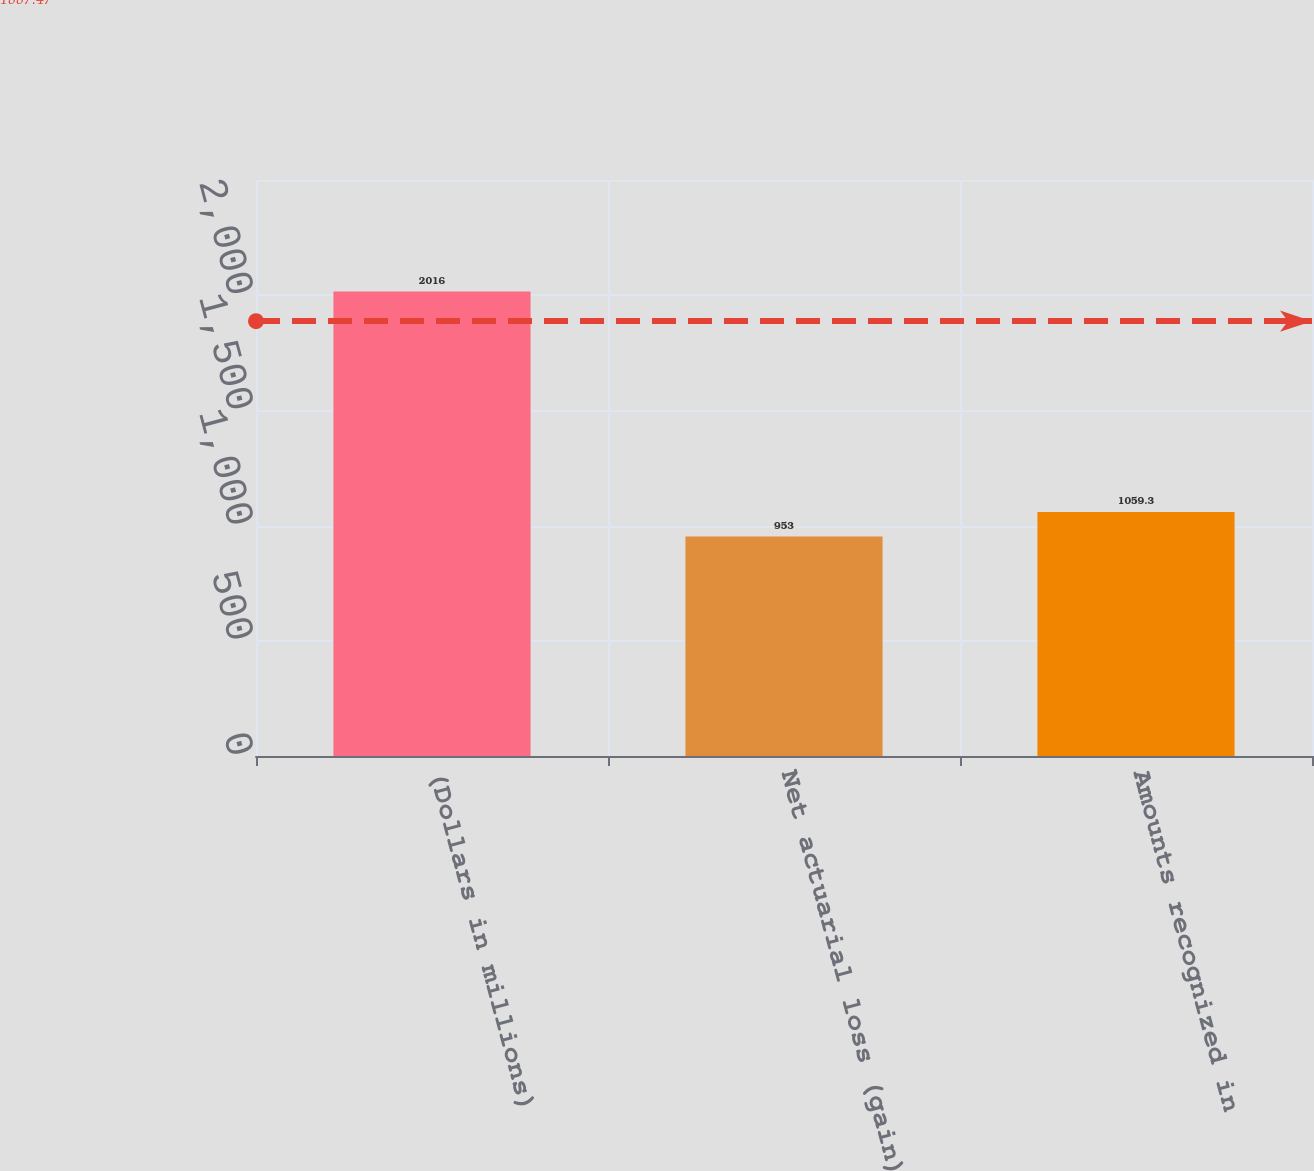Convert chart to OTSL. <chart><loc_0><loc_0><loc_500><loc_500><bar_chart><fcel>(Dollars in millions)<fcel>Net actuarial loss (gain)<fcel>Amounts recognized in<nl><fcel>2016<fcel>953<fcel>1059.3<nl></chart> 